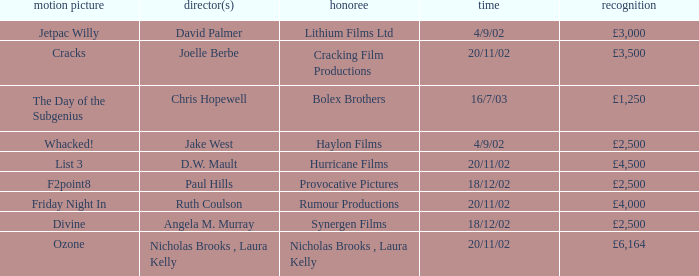Who directed a film for Cracking Film Productions? Joelle Berbe. 